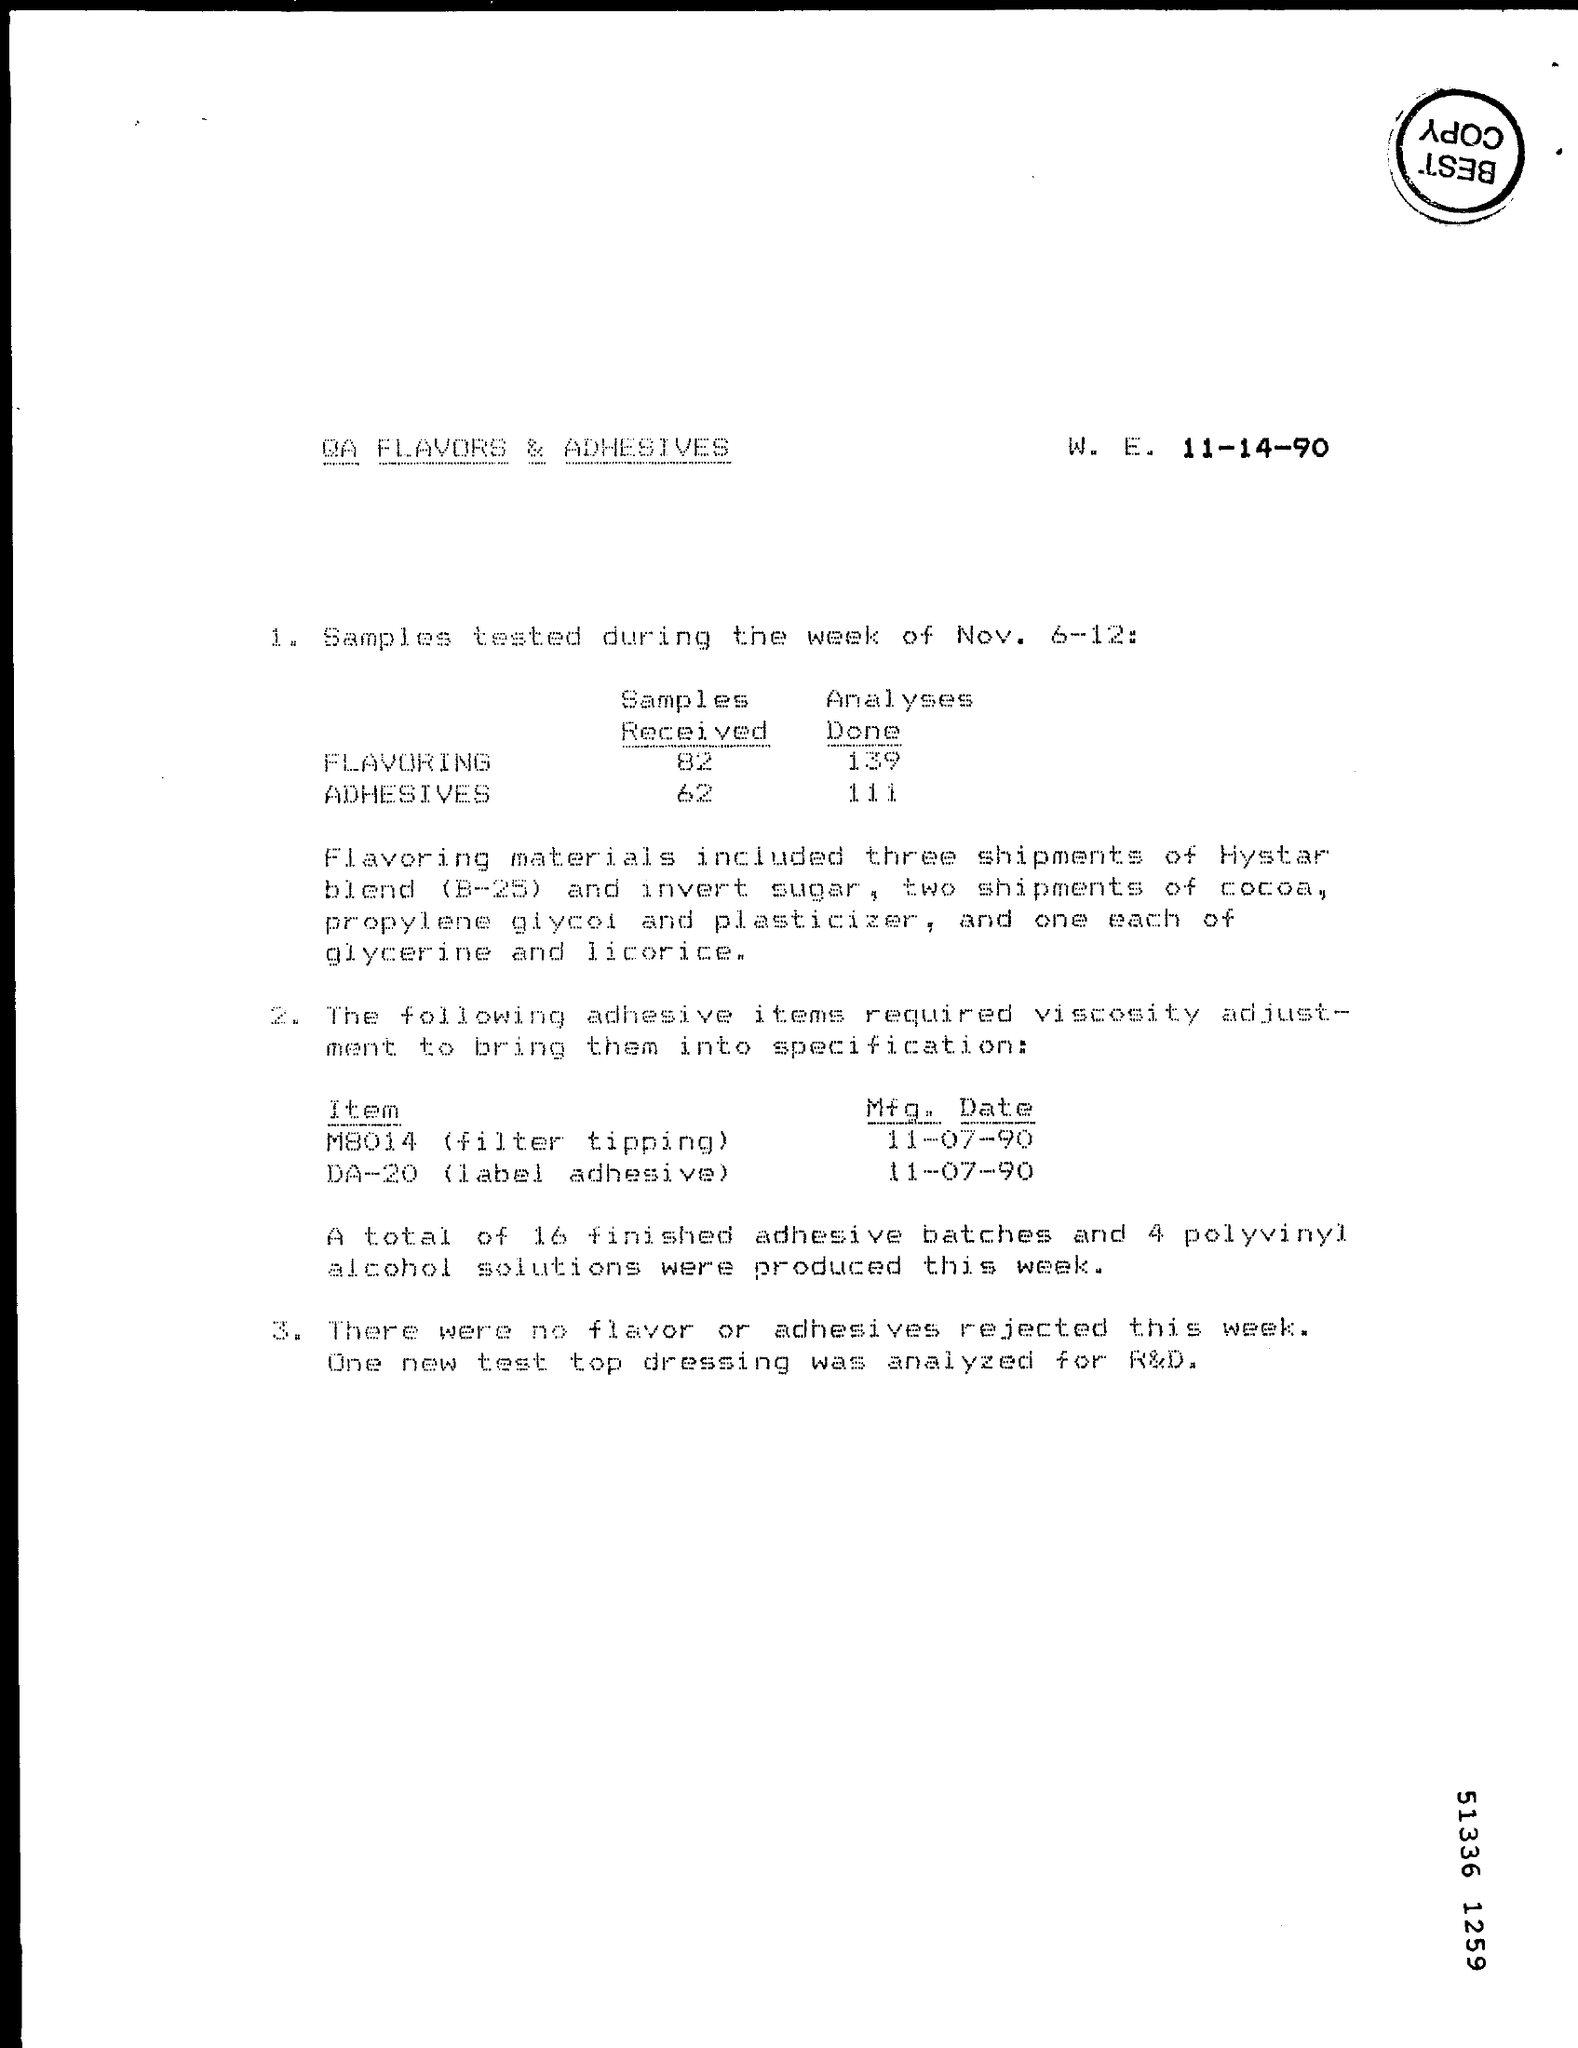Identify some key points in this picture. The manufacturing date for item M8014 (filter tipping) is November 7th, 1990. The title of the document is QA Flavors & Adhesives. The manufacturing date for Item DA-20 (label adhesive) is November 7th, 1990. 